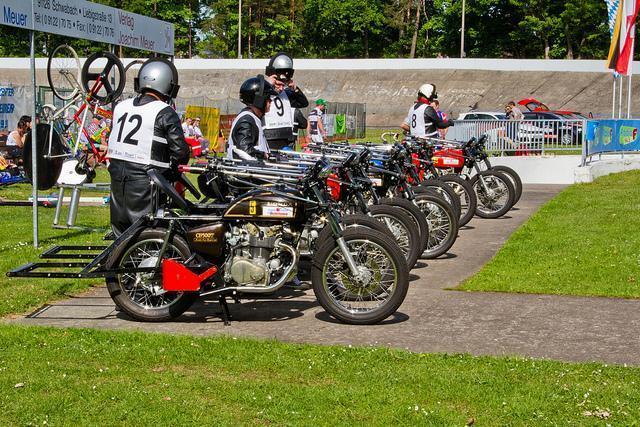How many different numbers do you see?
Give a very brief answer. 3. How many motorcycles can you see?
Give a very brief answer. 5. How many people are in the picture?
Give a very brief answer. 3. How many ski poles are clearly visible in this picture?
Give a very brief answer. 0. 